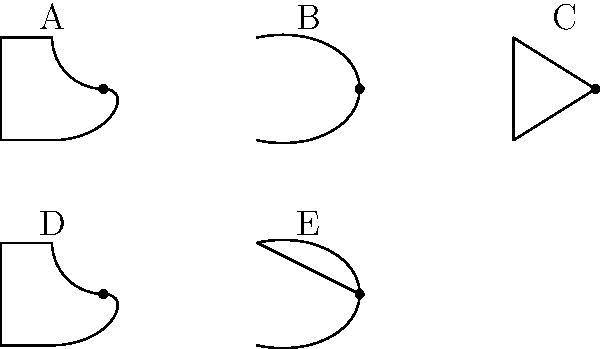As an alumni from Lyme Academy of Fine Arts, you've been tasked with creating a visual guide for basic logic gates in an introductory electrical engineering course. Identify the logic gates represented by symbols A, B, C, D, and E in the image above. Which of these gates performs the NOT operation on the result of another gate? Let's identify each logic gate symbol and its function:

1. Symbol A: This is an AND gate. It outputs 1 only when all inputs are 1.

2. Symbol B: This is an OR gate. It outputs 1 if at least one input is 1.

3. Symbol C: This is a NOT gate (also called an inverter). It outputs the opposite of its input.

4. Symbol D: This is a NAND gate. It performs an AND operation followed by a NOT operation.

5. Symbol E: This is a NOR gate. It performs an OR operation followed by a NOT operation.

To answer which gate performs the NOT operation on the result of another gate, we need to look for compound gates. Both NAND and NOR gates fit this description:

- NAND (D) performs NOT on the result of AND
- NOR (E) performs NOT on the result of OR

Therefore, both D (NAND) and E (NOR) perform the NOT operation on the result of another gate.
Answer: D (NAND) and E (NOR) 